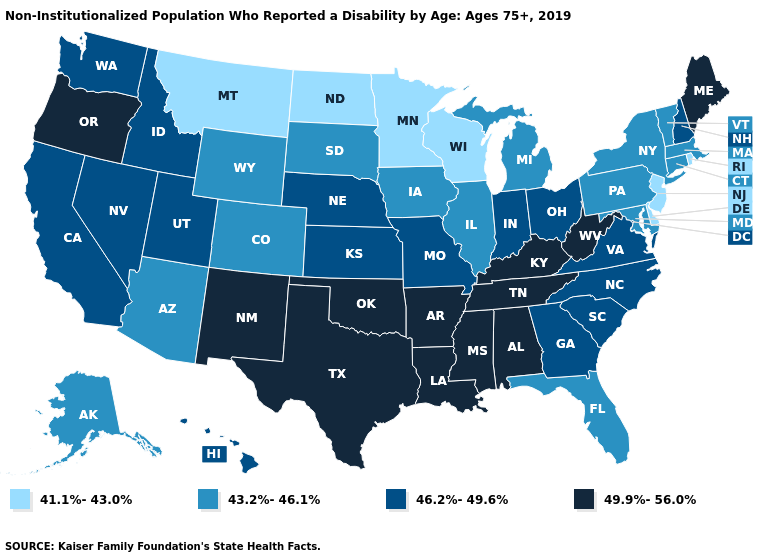Name the states that have a value in the range 49.9%-56.0%?
Keep it brief. Alabama, Arkansas, Kentucky, Louisiana, Maine, Mississippi, New Mexico, Oklahoma, Oregon, Tennessee, Texas, West Virginia. What is the highest value in the South ?
Write a very short answer. 49.9%-56.0%. What is the highest value in states that border Massachusetts?
Answer briefly. 46.2%-49.6%. Does Michigan have a higher value than Alaska?
Answer briefly. No. Does the first symbol in the legend represent the smallest category?
Write a very short answer. Yes. Among the states that border Montana , which have the lowest value?
Quick response, please. North Dakota. Among the states that border California , which have the lowest value?
Short answer required. Arizona. What is the lowest value in states that border Delaware?
Answer briefly. 41.1%-43.0%. What is the lowest value in the USA?
Give a very brief answer. 41.1%-43.0%. Name the states that have a value in the range 43.2%-46.1%?
Short answer required. Alaska, Arizona, Colorado, Connecticut, Florida, Illinois, Iowa, Maryland, Massachusetts, Michigan, New York, Pennsylvania, South Dakota, Vermont, Wyoming. Among the states that border North Carolina , which have the lowest value?
Be succinct. Georgia, South Carolina, Virginia. Which states have the lowest value in the Northeast?
Give a very brief answer. New Jersey, Rhode Island. Among the states that border Colorado , does Wyoming have the lowest value?
Short answer required. Yes. Among the states that border New York , does Connecticut have the highest value?
Write a very short answer. Yes. Name the states that have a value in the range 49.9%-56.0%?
Concise answer only. Alabama, Arkansas, Kentucky, Louisiana, Maine, Mississippi, New Mexico, Oklahoma, Oregon, Tennessee, Texas, West Virginia. 